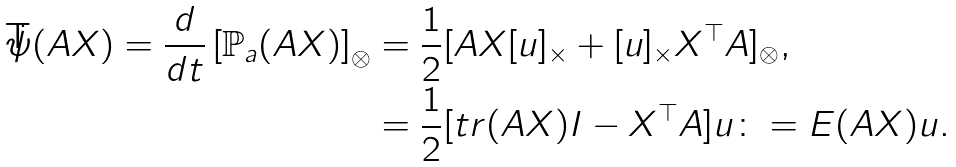Convert formula to latex. <formula><loc_0><loc_0><loc_500><loc_500>\dot { \psi } ( A X ) = \frac { d } { d t } \left [ \mathbb { P } _ { a } ( A X ) \right ] _ { \otimes } & = \frac { 1 } { 2 } [ A X [ u ] _ { \times } + [ u ] _ { \times } X ^ { \top } A ] _ { \otimes } , \\ & = \frac { 1 } { 2 } [ t r ( A X ) I - X ^ { \top } A ] u \colon = E ( A X ) u .</formula> 